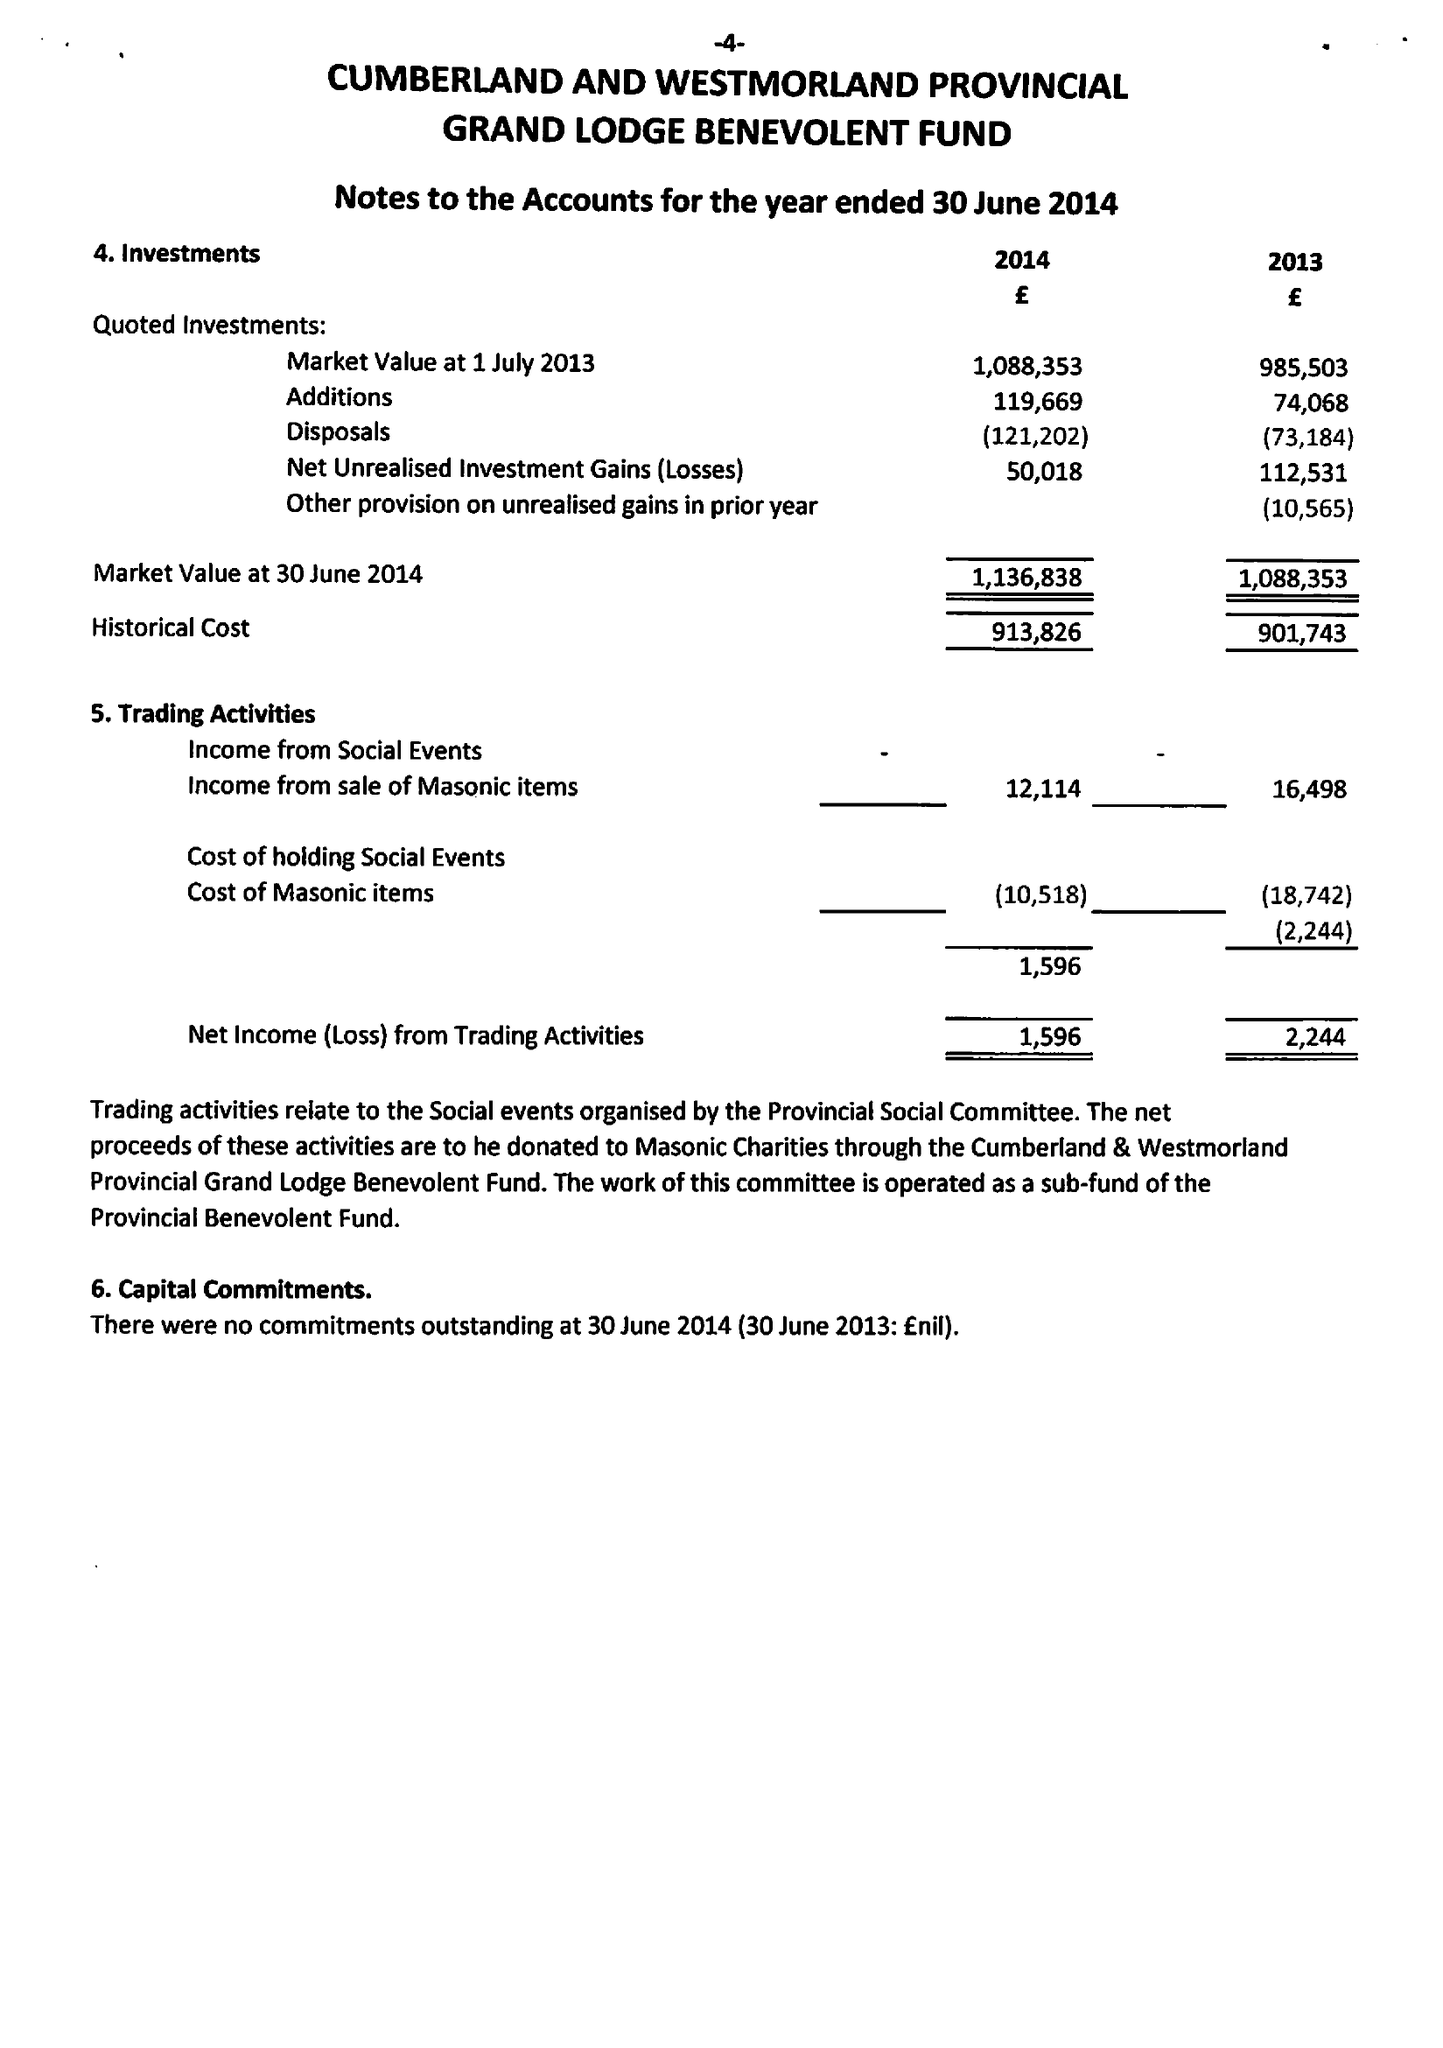What is the value for the address__street_line?
Answer the question using a single word or phrase. None 